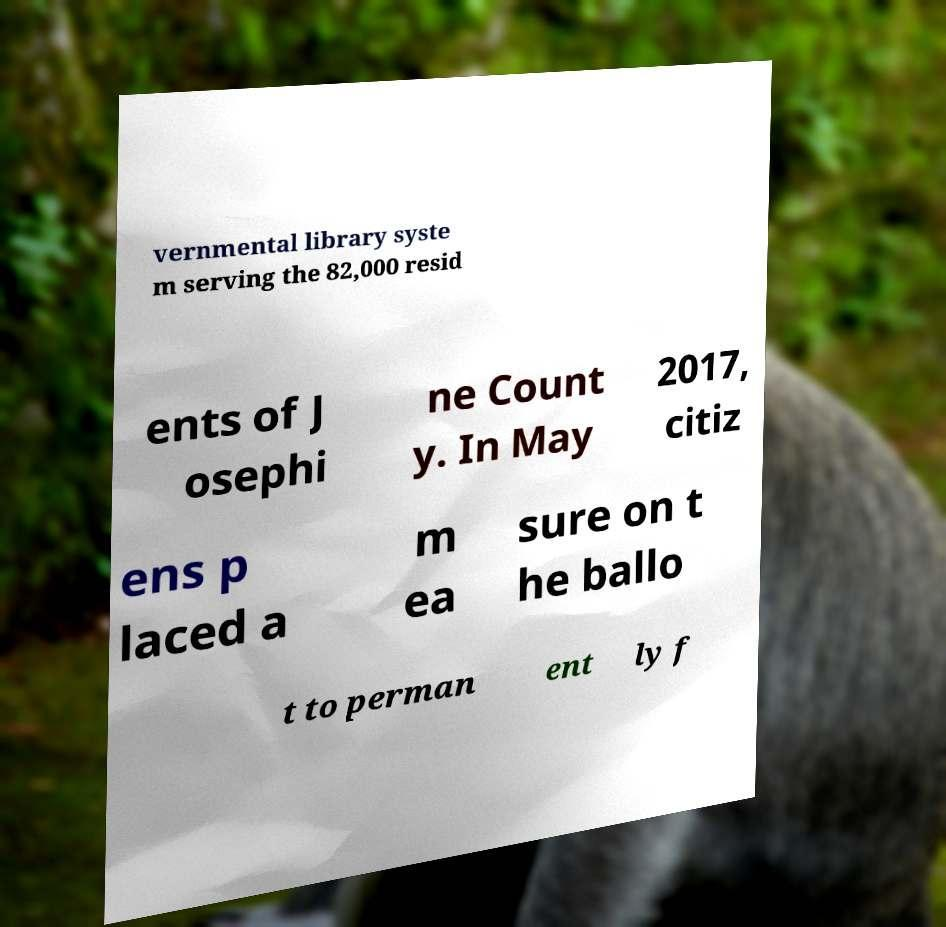Can you read and provide the text displayed in the image?This photo seems to have some interesting text. Can you extract and type it out for me? vernmental library syste m serving the 82,000 resid ents of J osephi ne Count y. In May 2017, citiz ens p laced a m ea sure on t he ballo t to perman ent ly f 